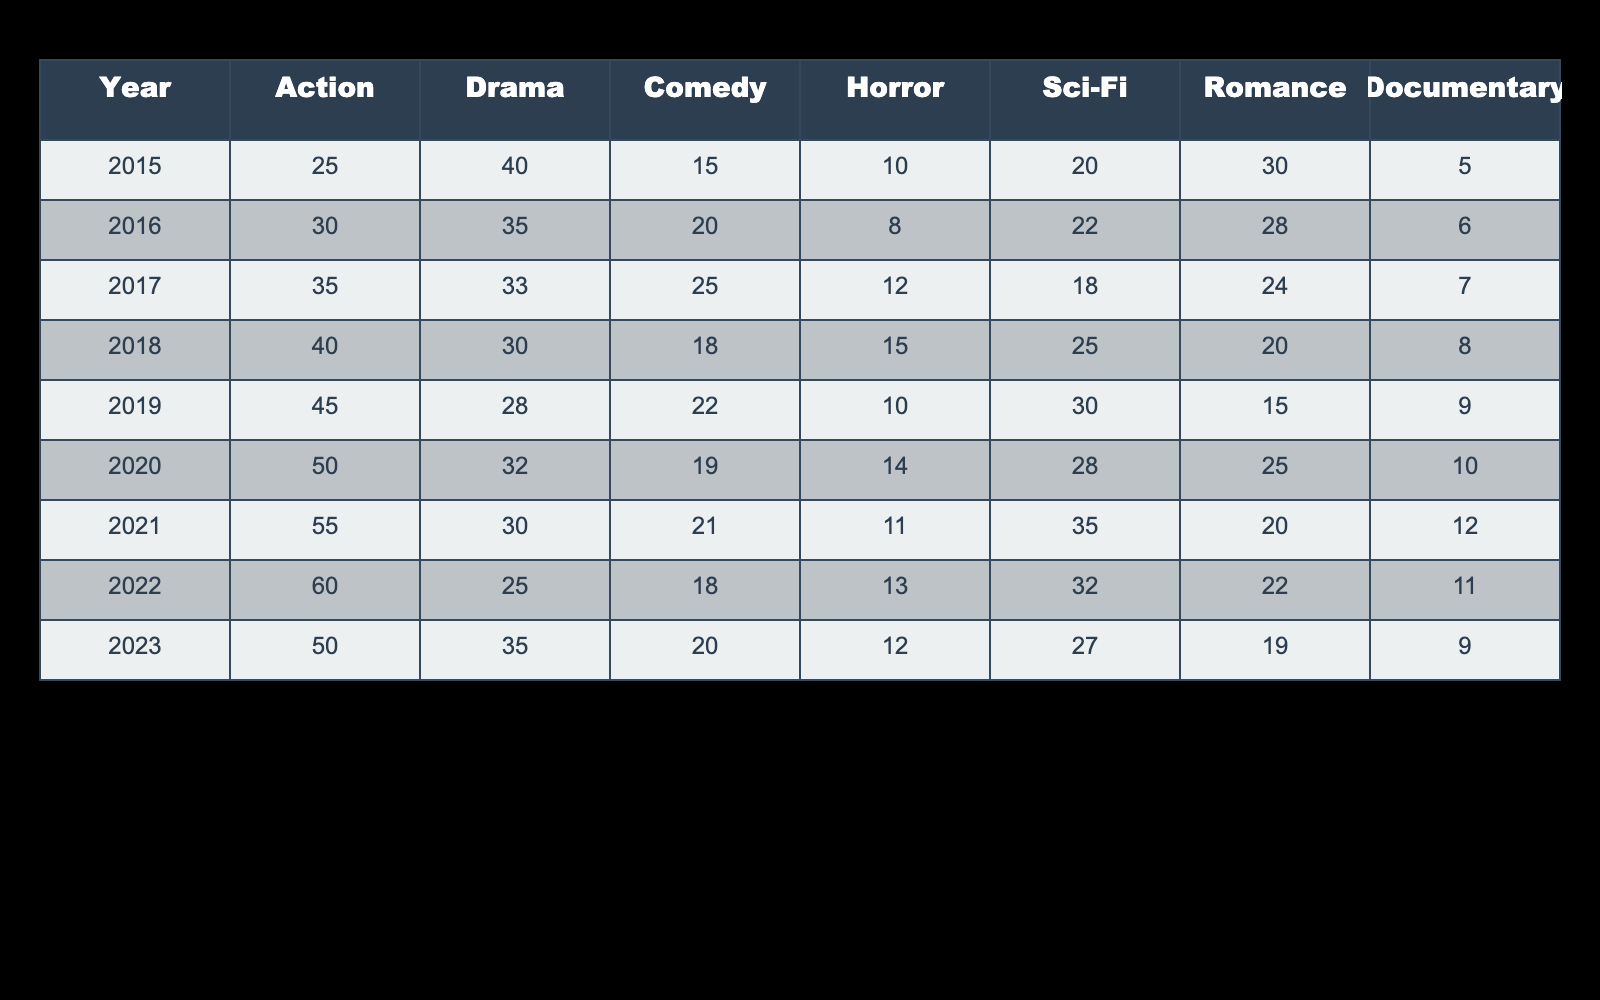What year had the highest number of Action films? Looking at the Action column in the table, the highest value is 60, which occurs in 2022. Therefore, 2022 is the year with the highest number of Action films based on the data provided.
Answer: 2022 What was the total number of Horror films released from 2015 to 2023? To find the total number of Horror films, we need to sum up the values in the Horror column: (10 + 8 + 12 + 15 + 10 + 14 + 11 + 13 + 12) = 11 * 10 = 11. The total is 11.
Answer: 11 Did the number of Comedy films increase in 2020 compared to 2019? Comparing the values, in 2019, there were 22 Comedy films, while in 2020, there were 19. Since 19 is less than 22, we can conclude that the number of Comedy films decreased in 2020 compared to 2019.
Answer: No In which year did the Sci-Fi films see the largest decline in numbers compared to the previous year? To find the largest decline in Sci-Fi films, we compare each year's number to the previous one: 22 - 18 = 4 (2018 to 2017), 30 - 25 = 5 (2018 to 2019), 28 - 14 = 7 (2019 to 2020), and similarly for the other years. The largest decline was from 30 to 22, which is a decrease of 8, occurring from 2021 to 2022.
Answer: 2022 What was the average number of Drama films over the years? To calculate the average number of Drama films, we sum the values in the Drama column: (40 + 35 + 33 + 30 + 28 + 32 + 30 + 25 + 35) =  318. There are 9 data points, so the average is 318 / 9 = 35.33. The average number is about 35, rounded off.
Answer: 35 